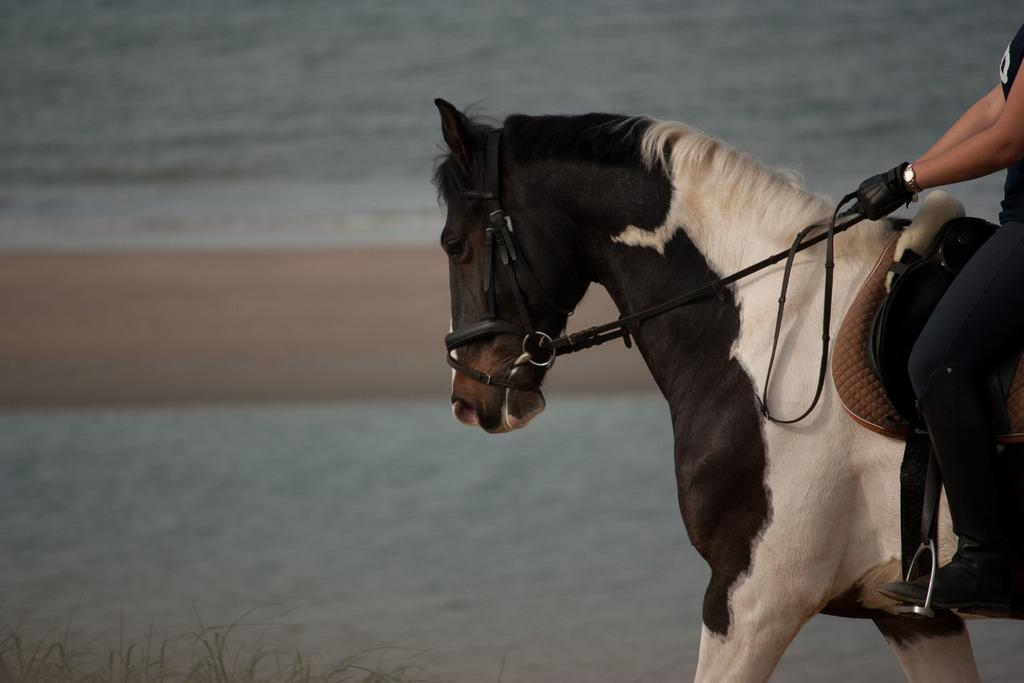What animal is present in the image? There is a horse in the image. What feature can be seen on the horse's head? The horse has a noseband. Who is riding the horse in the image? There is a person sitting on the horse. What can be seen in the background of the image? There is water visible in the image. What type of ant can be seen holding a whip in the image? There are no ants or whips present in the image; it features a horse with a person riding it and water in the background. 